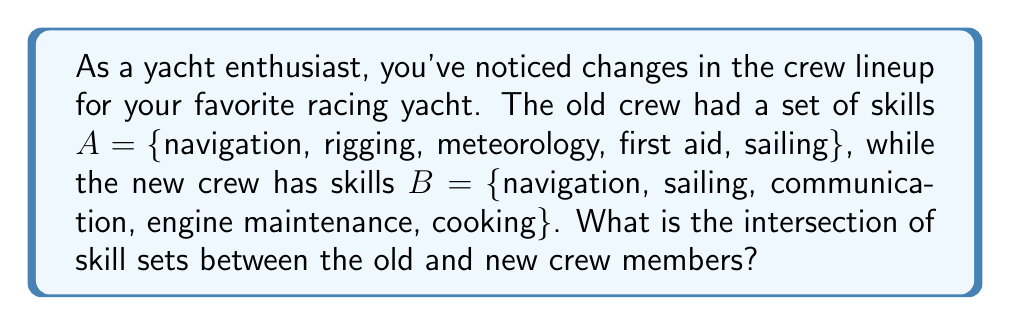Can you solve this math problem? To find the intersection of two sets, we need to identify the elements that are common to both sets. Let's approach this step-by-step:

1. We have two sets:
   $A = \{navigation, rigging, meteorology, first\ aid, sailing\}$
   $B = \{navigation, sailing, communication, engine\ maintenance, cooking\}$

2. The intersection of sets A and B is denoted as $A \cap B$, which contains all elements that are in both A and B.

3. Let's compare each element:
   - navigation: present in both A and B
   - rigging: only in A
   - meteorology: only in A
   - first aid: only in A
   - sailing: present in both A and B
   - communication: only in B
   - engine maintenance: only in B
   - cooking: only in B

4. The elements that appear in both sets are "navigation" and "sailing".

Therefore, the intersection of the skill sets is:

$A \cap B = \{navigation, sailing\}$

This means that the skills common to both the old and new crew are navigation and sailing.
Answer: $A \cap B = \{navigation, sailing\}$ 